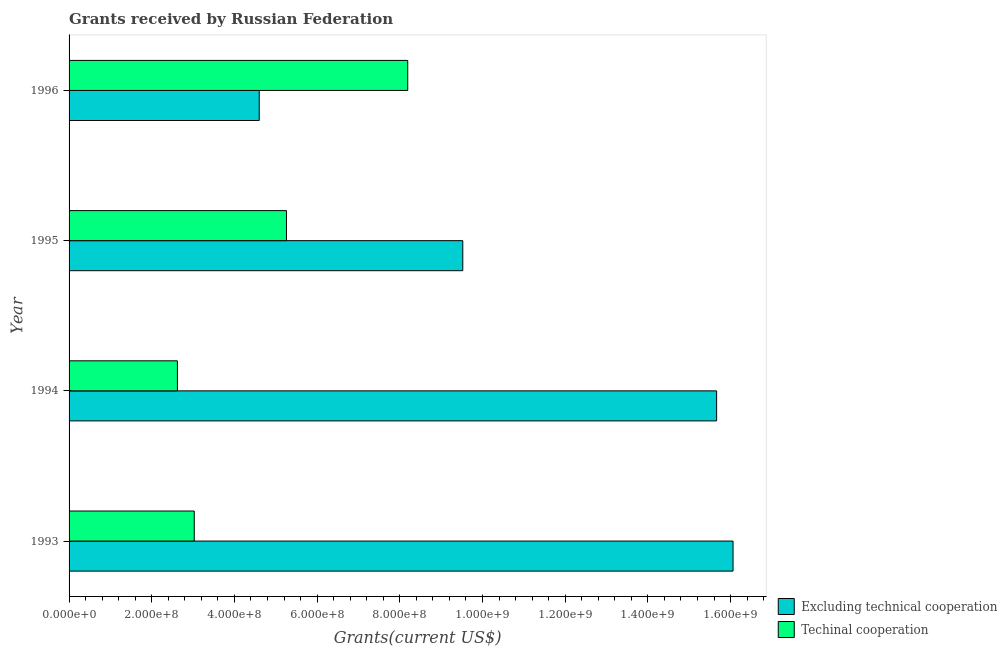Are the number of bars per tick equal to the number of legend labels?
Keep it short and to the point. Yes. How many bars are there on the 2nd tick from the top?
Give a very brief answer. 2. What is the label of the 3rd group of bars from the top?
Provide a succinct answer. 1994. What is the amount of grants received(including technical cooperation) in 1996?
Offer a terse response. 8.19e+08. Across all years, what is the maximum amount of grants received(including technical cooperation)?
Give a very brief answer. 8.19e+08. Across all years, what is the minimum amount of grants received(excluding technical cooperation)?
Offer a very short reply. 4.60e+08. In which year was the amount of grants received(including technical cooperation) maximum?
Give a very brief answer. 1996. What is the total amount of grants received(excluding technical cooperation) in the graph?
Keep it short and to the point. 4.58e+09. What is the difference between the amount of grants received(including technical cooperation) in 1994 and that in 1996?
Provide a succinct answer. -5.57e+08. What is the difference between the amount of grants received(including technical cooperation) in 1996 and the amount of grants received(excluding technical cooperation) in 1995?
Ensure brevity in your answer.  -1.33e+08. What is the average amount of grants received(including technical cooperation) per year?
Provide a succinct answer. 4.77e+08. In the year 1995, what is the difference between the amount of grants received(excluding technical cooperation) and amount of grants received(including technical cooperation)?
Give a very brief answer. 4.26e+08. What is the ratio of the amount of grants received(including technical cooperation) in 1993 to that in 1994?
Ensure brevity in your answer.  1.16. Is the difference between the amount of grants received(including technical cooperation) in 1994 and 1995 greater than the difference between the amount of grants received(excluding technical cooperation) in 1994 and 1995?
Give a very brief answer. No. What is the difference between the highest and the second highest amount of grants received(including technical cooperation)?
Ensure brevity in your answer.  2.93e+08. What is the difference between the highest and the lowest amount of grants received(excluding technical cooperation)?
Your answer should be very brief. 1.15e+09. What does the 1st bar from the top in 1996 represents?
Offer a terse response. Techinal cooperation. What does the 2nd bar from the bottom in 1993 represents?
Provide a short and direct response. Techinal cooperation. How many bars are there?
Your response must be concise. 8. How many years are there in the graph?
Your answer should be very brief. 4. Are the values on the major ticks of X-axis written in scientific E-notation?
Your answer should be compact. Yes. Does the graph contain grids?
Your answer should be compact. No. Where does the legend appear in the graph?
Your response must be concise. Bottom right. How many legend labels are there?
Offer a terse response. 2. What is the title of the graph?
Offer a very short reply. Grants received by Russian Federation. Does "Working only" appear as one of the legend labels in the graph?
Your answer should be very brief. No. What is the label or title of the X-axis?
Make the answer very short. Grants(current US$). What is the label or title of the Y-axis?
Give a very brief answer. Year. What is the Grants(current US$) in Excluding technical cooperation in 1993?
Offer a terse response. 1.61e+09. What is the Grants(current US$) in Techinal cooperation in 1993?
Offer a very short reply. 3.03e+08. What is the Grants(current US$) of Excluding technical cooperation in 1994?
Offer a terse response. 1.57e+09. What is the Grants(current US$) of Techinal cooperation in 1994?
Ensure brevity in your answer.  2.62e+08. What is the Grants(current US$) of Excluding technical cooperation in 1995?
Ensure brevity in your answer.  9.52e+08. What is the Grants(current US$) in Techinal cooperation in 1995?
Your response must be concise. 5.26e+08. What is the Grants(current US$) in Excluding technical cooperation in 1996?
Offer a very short reply. 4.60e+08. What is the Grants(current US$) of Techinal cooperation in 1996?
Provide a short and direct response. 8.19e+08. Across all years, what is the maximum Grants(current US$) in Excluding technical cooperation?
Offer a very short reply. 1.61e+09. Across all years, what is the maximum Grants(current US$) in Techinal cooperation?
Offer a terse response. 8.19e+08. Across all years, what is the minimum Grants(current US$) in Excluding technical cooperation?
Make the answer very short. 4.60e+08. Across all years, what is the minimum Grants(current US$) in Techinal cooperation?
Your answer should be very brief. 2.62e+08. What is the total Grants(current US$) in Excluding technical cooperation in the graph?
Ensure brevity in your answer.  4.58e+09. What is the total Grants(current US$) of Techinal cooperation in the graph?
Your answer should be very brief. 1.91e+09. What is the difference between the Grants(current US$) in Excluding technical cooperation in 1993 and that in 1994?
Offer a very short reply. 3.97e+07. What is the difference between the Grants(current US$) in Techinal cooperation in 1993 and that in 1994?
Your answer should be very brief. 4.07e+07. What is the difference between the Grants(current US$) in Excluding technical cooperation in 1993 and that in 1995?
Provide a short and direct response. 6.54e+08. What is the difference between the Grants(current US$) of Techinal cooperation in 1993 and that in 1995?
Provide a short and direct response. -2.23e+08. What is the difference between the Grants(current US$) of Excluding technical cooperation in 1993 and that in 1996?
Provide a succinct answer. 1.15e+09. What is the difference between the Grants(current US$) in Techinal cooperation in 1993 and that in 1996?
Make the answer very short. -5.16e+08. What is the difference between the Grants(current US$) in Excluding technical cooperation in 1994 and that in 1995?
Provide a short and direct response. 6.14e+08. What is the difference between the Grants(current US$) in Techinal cooperation in 1994 and that in 1995?
Make the answer very short. -2.64e+08. What is the difference between the Grants(current US$) in Excluding technical cooperation in 1994 and that in 1996?
Make the answer very short. 1.11e+09. What is the difference between the Grants(current US$) of Techinal cooperation in 1994 and that in 1996?
Offer a terse response. -5.57e+08. What is the difference between the Grants(current US$) in Excluding technical cooperation in 1995 and that in 1996?
Ensure brevity in your answer.  4.92e+08. What is the difference between the Grants(current US$) in Techinal cooperation in 1995 and that in 1996?
Your answer should be very brief. -2.93e+08. What is the difference between the Grants(current US$) in Excluding technical cooperation in 1993 and the Grants(current US$) in Techinal cooperation in 1994?
Your answer should be compact. 1.34e+09. What is the difference between the Grants(current US$) of Excluding technical cooperation in 1993 and the Grants(current US$) of Techinal cooperation in 1995?
Keep it short and to the point. 1.08e+09. What is the difference between the Grants(current US$) in Excluding technical cooperation in 1993 and the Grants(current US$) in Techinal cooperation in 1996?
Make the answer very short. 7.87e+08. What is the difference between the Grants(current US$) of Excluding technical cooperation in 1994 and the Grants(current US$) of Techinal cooperation in 1995?
Offer a terse response. 1.04e+09. What is the difference between the Grants(current US$) in Excluding technical cooperation in 1994 and the Grants(current US$) in Techinal cooperation in 1996?
Provide a succinct answer. 7.47e+08. What is the difference between the Grants(current US$) of Excluding technical cooperation in 1995 and the Grants(current US$) of Techinal cooperation in 1996?
Offer a very short reply. 1.33e+08. What is the average Grants(current US$) of Excluding technical cooperation per year?
Your answer should be very brief. 1.15e+09. What is the average Grants(current US$) of Techinal cooperation per year?
Offer a very short reply. 4.77e+08. In the year 1993, what is the difference between the Grants(current US$) in Excluding technical cooperation and Grants(current US$) in Techinal cooperation?
Provide a short and direct response. 1.30e+09. In the year 1994, what is the difference between the Grants(current US$) of Excluding technical cooperation and Grants(current US$) of Techinal cooperation?
Offer a very short reply. 1.30e+09. In the year 1995, what is the difference between the Grants(current US$) of Excluding technical cooperation and Grants(current US$) of Techinal cooperation?
Make the answer very short. 4.26e+08. In the year 1996, what is the difference between the Grants(current US$) in Excluding technical cooperation and Grants(current US$) in Techinal cooperation?
Your answer should be compact. -3.59e+08. What is the ratio of the Grants(current US$) in Excluding technical cooperation in 1993 to that in 1994?
Provide a short and direct response. 1.03. What is the ratio of the Grants(current US$) in Techinal cooperation in 1993 to that in 1994?
Provide a succinct answer. 1.16. What is the ratio of the Grants(current US$) of Excluding technical cooperation in 1993 to that in 1995?
Your answer should be compact. 1.69. What is the ratio of the Grants(current US$) of Techinal cooperation in 1993 to that in 1995?
Provide a succinct answer. 0.58. What is the ratio of the Grants(current US$) in Excluding technical cooperation in 1993 to that in 1996?
Your answer should be compact. 3.49. What is the ratio of the Grants(current US$) of Techinal cooperation in 1993 to that in 1996?
Your answer should be very brief. 0.37. What is the ratio of the Grants(current US$) of Excluding technical cooperation in 1994 to that in 1995?
Offer a terse response. 1.64. What is the ratio of the Grants(current US$) in Techinal cooperation in 1994 to that in 1995?
Provide a succinct answer. 0.5. What is the ratio of the Grants(current US$) in Excluding technical cooperation in 1994 to that in 1996?
Offer a very short reply. 3.41. What is the ratio of the Grants(current US$) in Techinal cooperation in 1994 to that in 1996?
Keep it short and to the point. 0.32. What is the ratio of the Grants(current US$) in Excluding technical cooperation in 1995 to that in 1996?
Ensure brevity in your answer.  2.07. What is the ratio of the Grants(current US$) of Techinal cooperation in 1995 to that in 1996?
Offer a very short reply. 0.64. What is the difference between the highest and the second highest Grants(current US$) in Excluding technical cooperation?
Offer a terse response. 3.97e+07. What is the difference between the highest and the second highest Grants(current US$) in Techinal cooperation?
Give a very brief answer. 2.93e+08. What is the difference between the highest and the lowest Grants(current US$) in Excluding technical cooperation?
Offer a very short reply. 1.15e+09. What is the difference between the highest and the lowest Grants(current US$) of Techinal cooperation?
Provide a succinct answer. 5.57e+08. 